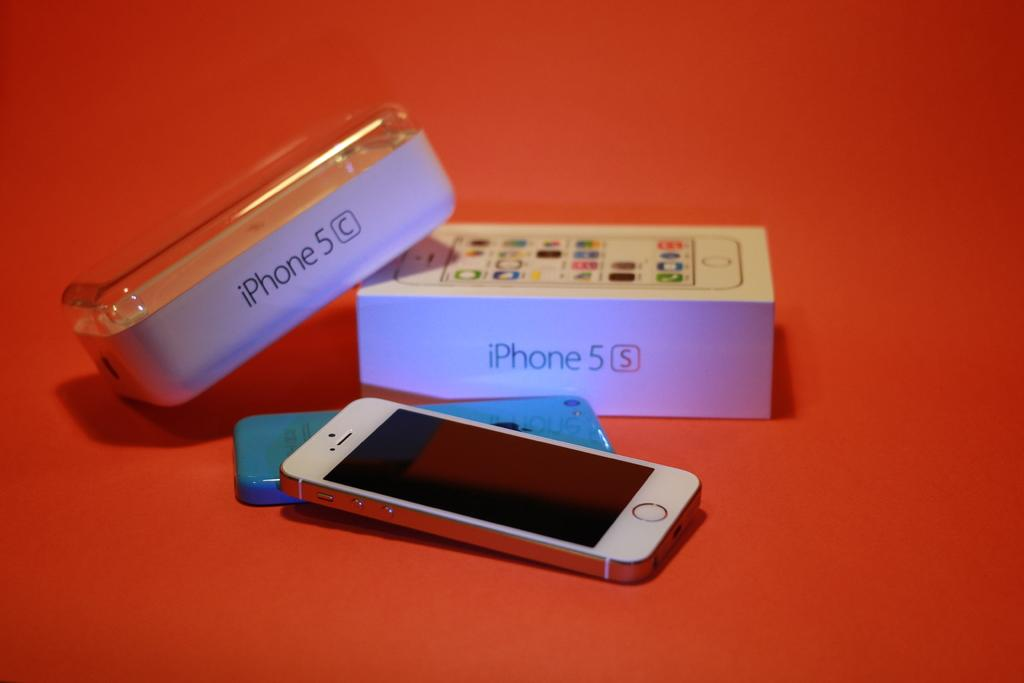<image>
Write a terse but informative summary of the picture. Two iPhone 5 boxes sit next to each other, one from a C model and one from an S model. 